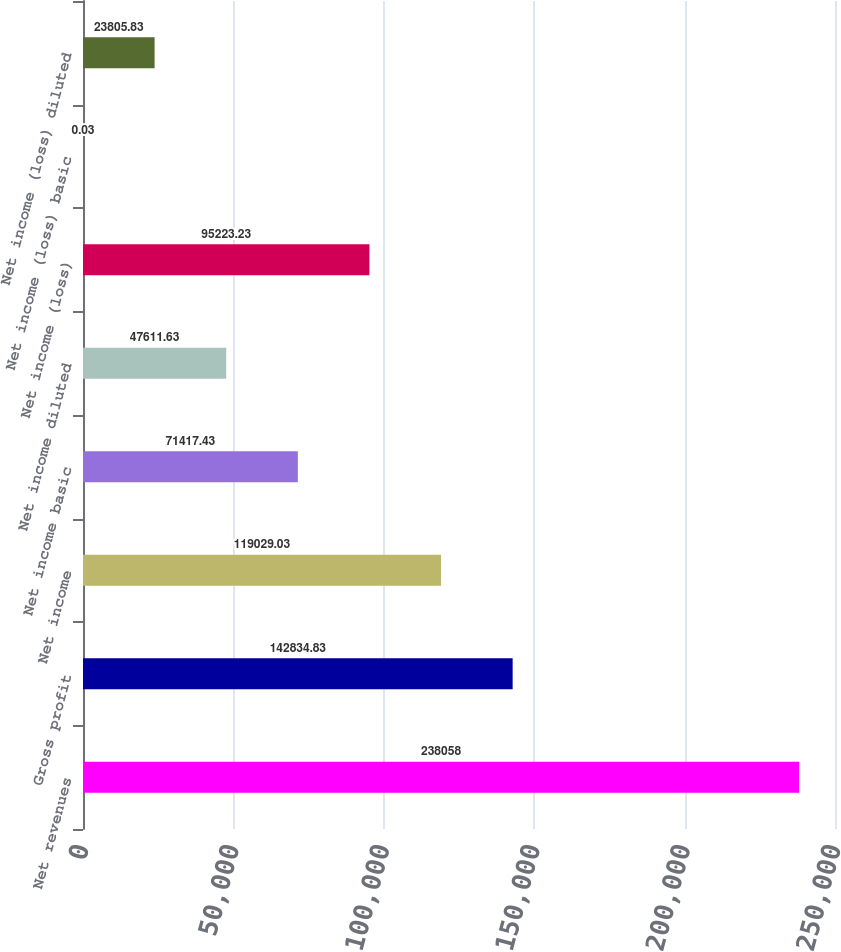<chart> <loc_0><loc_0><loc_500><loc_500><bar_chart><fcel>Net revenues<fcel>Gross profit<fcel>Net income<fcel>Net income basic<fcel>Net income diluted<fcel>Net income (loss)<fcel>Net income (loss) basic<fcel>Net income (loss) diluted<nl><fcel>238058<fcel>142835<fcel>119029<fcel>71417.4<fcel>47611.6<fcel>95223.2<fcel>0.03<fcel>23805.8<nl></chart> 